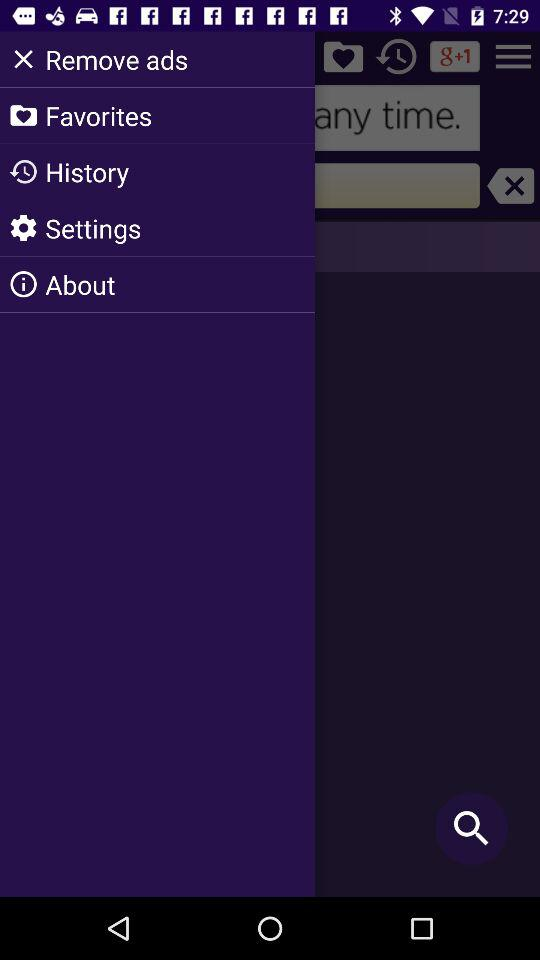How many hearts are on the screen?
Answer the question using a single word or phrase. 2 